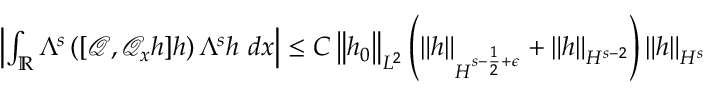<formula> <loc_0><loc_0><loc_500><loc_500>\begin{array} { r } { \left | \int _ { \mathbb { R } } \Lambda ^ { s } \left ( [ \ m a t h s c r { Q } , \ m a t h s c r { Q } _ { x } h ] h \right ) \Lambda ^ { s } h \ d x \right | \leq C \left \| h _ { 0 } \right \| _ { L ^ { 2 } } \left ( \left \| h \right \| _ { H ^ { s - \frac { 1 } { 2 } + \epsilon } } + \left \| h \right \| _ { H ^ { s - 2 } } \right ) \left \| h \right \| _ { H ^ { s } } } \end{array}</formula> 